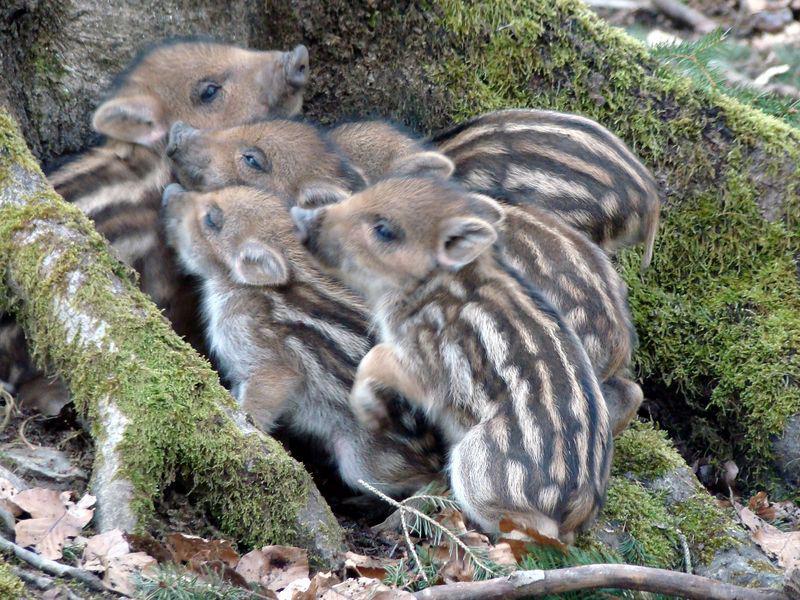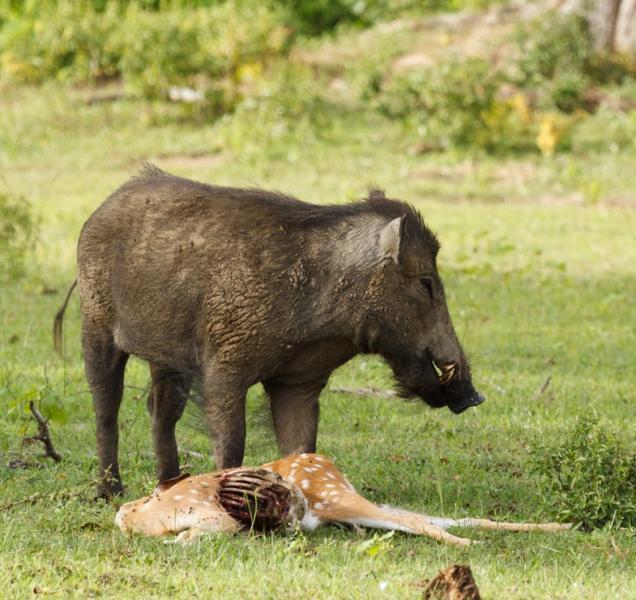The first image is the image on the left, the second image is the image on the right. For the images displayed, is the sentence "There are at least two animals in the image on the left." factually correct? Answer yes or no. Yes. 